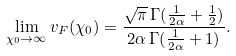<formula> <loc_0><loc_0><loc_500><loc_500>\lim _ { \chi _ { 0 } \to \infty } v _ { F } ( \chi _ { 0 } ) = \frac { \sqrt { \pi } \, \Gamma ( \frac { 1 } { 2 \alpha } + \frac { 1 } { 2 } ) } { 2 \alpha \, \Gamma ( \frac { 1 } { 2 \alpha } + 1 ) } .</formula> 